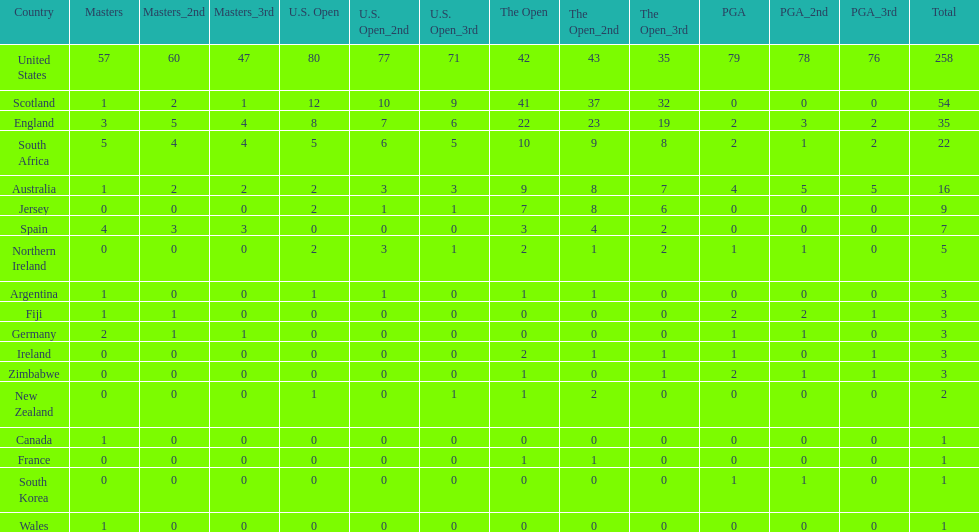What are all the countries? United States, Scotland, England, South Africa, Australia, Jersey, Spain, Northern Ireland, Argentina, Fiji, Germany, Ireland, Zimbabwe, New Zealand, Canada, France, South Korea, Wales. Which ones are located in africa? South Africa, Zimbabwe. Of those, which has the least champion golfers? Zimbabwe. 